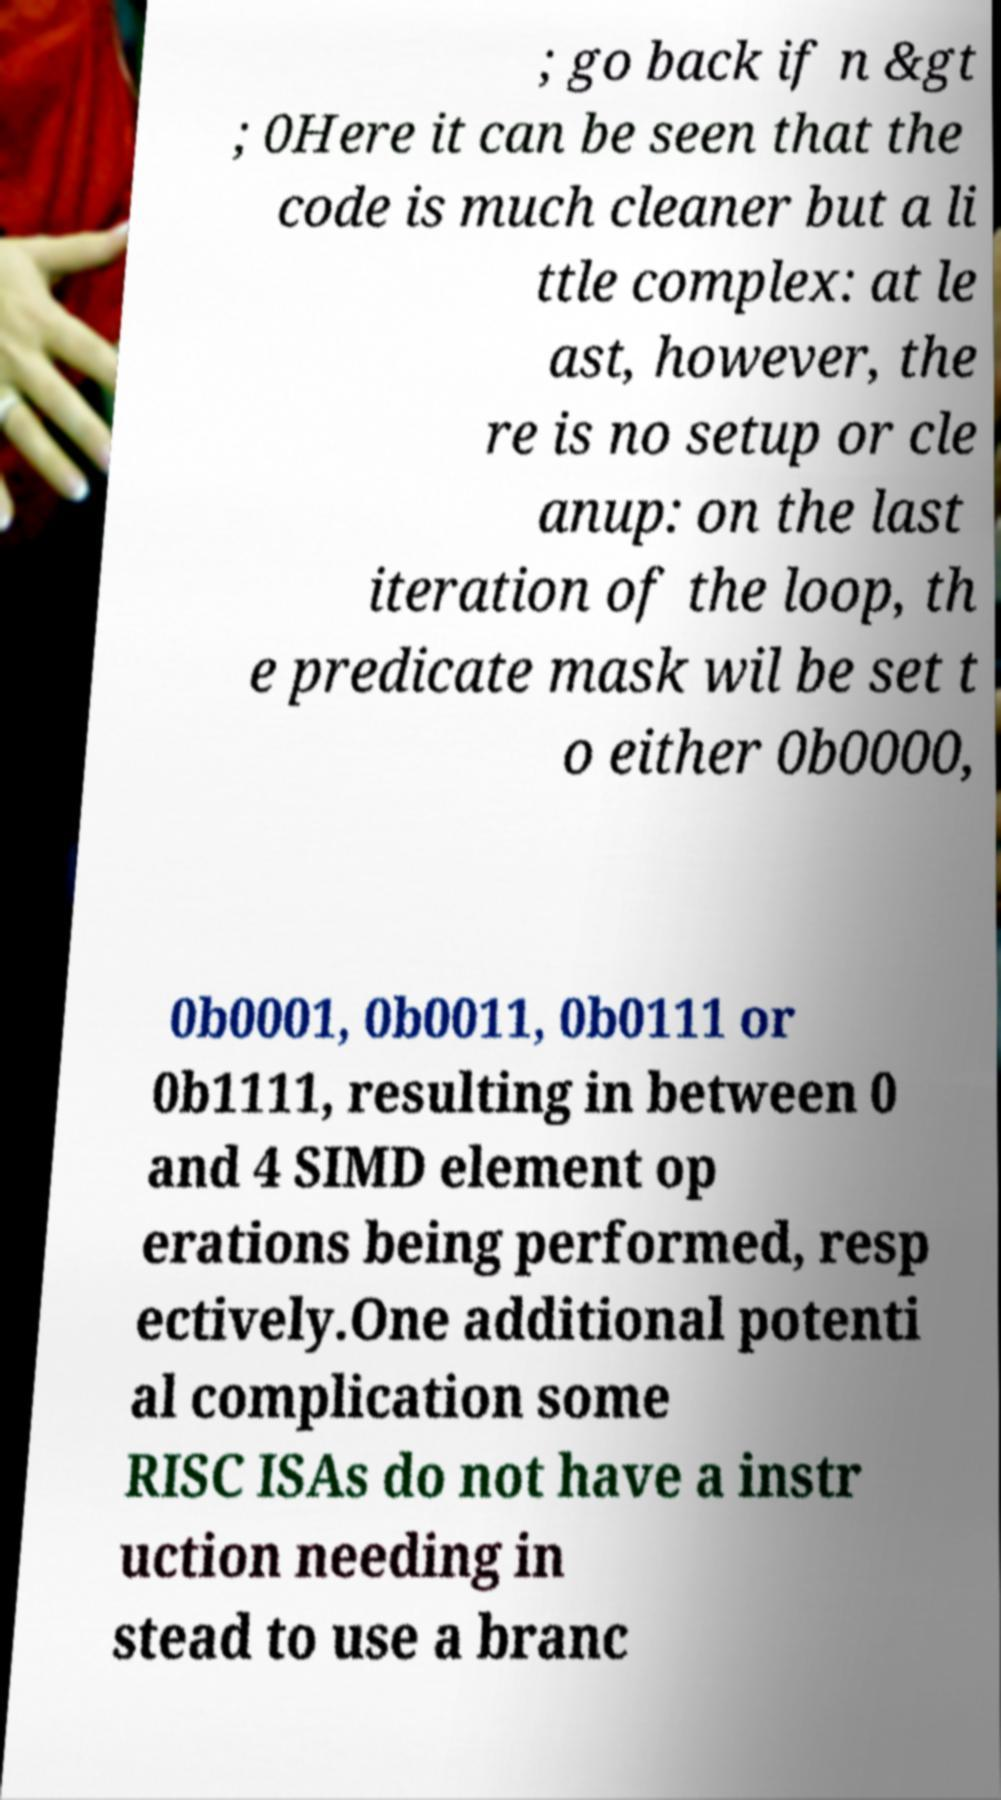Could you assist in decoding the text presented in this image and type it out clearly? ; go back if n &gt ; 0Here it can be seen that the code is much cleaner but a li ttle complex: at le ast, however, the re is no setup or cle anup: on the last iteration of the loop, th e predicate mask wil be set t o either 0b0000, 0b0001, 0b0011, 0b0111 or 0b1111, resulting in between 0 and 4 SIMD element op erations being performed, resp ectively.One additional potenti al complication some RISC ISAs do not have a instr uction needing in stead to use a branc 